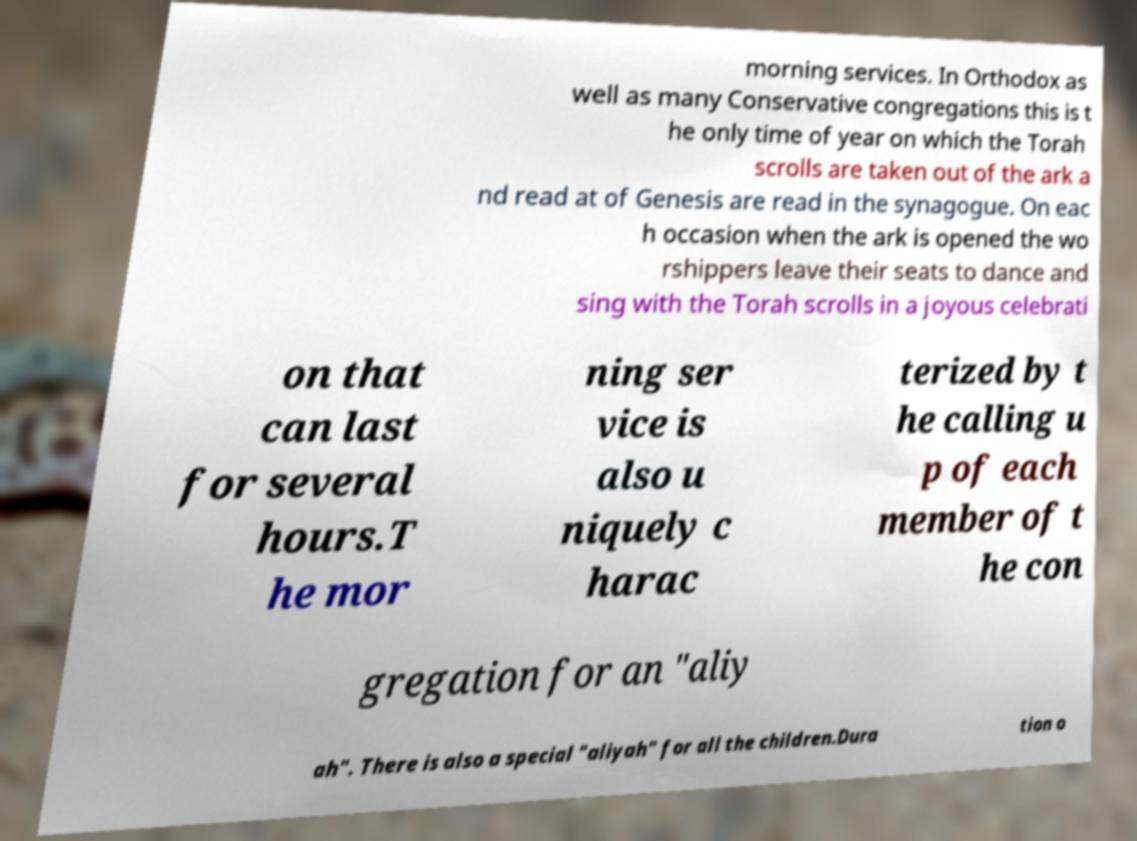There's text embedded in this image that I need extracted. Can you transcribe it verbatim? morning services. In Orthodox as well as many Conservative congregations this is t he only time of year on which the Torah scrolls are taken out of the ark a nd read at of Genesis are read in the synagogue. On eac h occasion when the ark is opened the wo rshippers leave their seats to dance and sing with the Torah scrolls in a joyous celebrati on that can last for several hours.T he mor ning ser vice is also u niquely c harac terized by t he calling u p of each member of t he con gregation for an "aliy ah". There is also a special "aliyah" for all the children.Dura tion o 